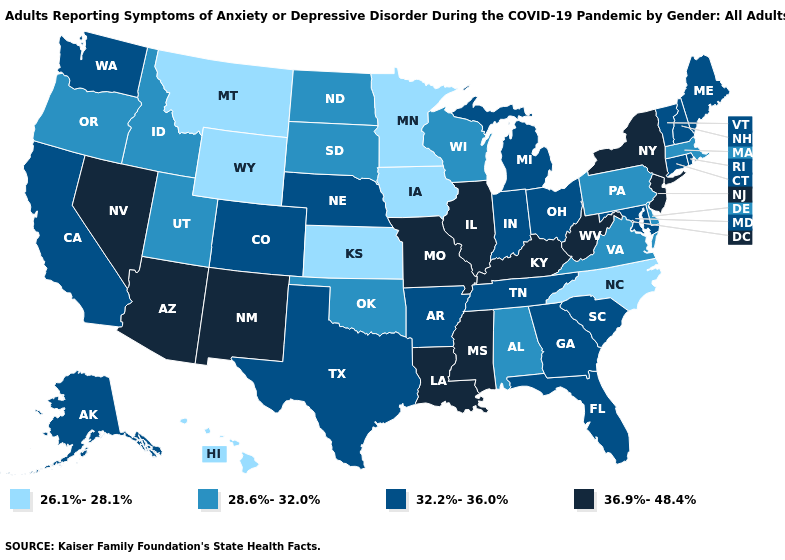Among the states that border Massachusetts , does Vermont have the lowest value?
Short answer required. Yes. Does Alaska have the same value as Colorado?
Concise answer only. Yes. How many symbols are there in the legend?
Write a very short answer. 4. Among the states that border Tennessee , does Kentucky have the highest value?
Write a very short answer. Yes. Name the states that have a value in the range 32.2%-36.0%?
Give a very brief answer. Alaska, Arkansas, California, Colorado, Connecticut, Florida, Georgia, Indiana, Maine, Maryland, Michigan, Nebraska, New Hampshire, Ohio, Rhode Island, South Carolina, Tennessee, Texas, Vermont, Washington. Which states hav the highest value in the West?
Answer briefly. Arizona, Nevada, New Mexico. What is the lowest value in the Northeast?
Write a very short answer. 28.6%-32.0%. What is the value of Indiana?
Be succinct. 32.2%-36.0%. Which states have the highest value in the USA?
Be succinct. Arizona, Illinois, Kentucky, Louisiana, Mississippi, Missouri, Nevada, New Jersey, New Mexico, New York, West Virginia. What is the value of Kentucky?
Quick response, please. 36.9%-48.4%. What is the value of New York?
Write a very short answer. 36.9%-48.4%. What is the value of Minnesota?
Answer briefly. 26.1%-28.1%. Name the states that have a value in the range 36.9%-48.4%?
Write a very short answer. Arizona, Illinois, Kentucky, Louisiana, Mississippi, Missouri, Nevada, New Jersey, New Mexico, New York, West Virginia. What is the lowest value in the USA?
Answer briefly. 26.1%-28.1%. What is the value of Delaware?
Give a very brief answer. 28.6%-32.0%. 